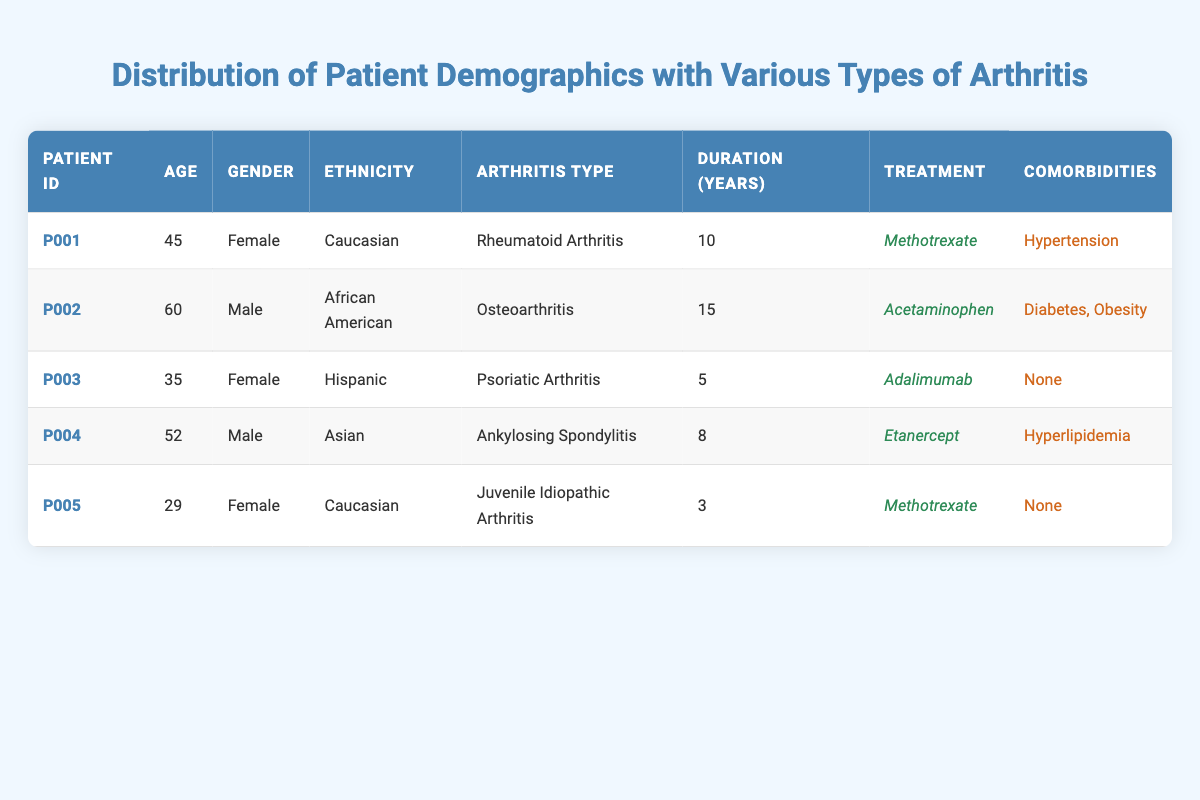What is the average age of the patients in the table? To find the average age, add together the ages of all patients (45 + 60 + 35 + 52 + 29 = 221) and divide by the number of patients (5). Thus, the average age is 221 / 5 = 44.2.
Answer: 44.2 How many patients have comorbidities? By examining the comorbidities column, it’s clear that patients P001, P002, and P004 have comorbidities. Therefore, there are three patients with comorbidities.
Answer: 3 Is there any patient who has been treated with Adalimumab? Patient P003 is listed in the table as receiving Adalimumab, confirming that there is indeed a patient using this treatment.
Answer: Yes What is the total duration of arthritis in years among all patients? To get the total duration, sum the duration years for all patients (10 + 15 + 5 + 8 + 3 = 41). This gives a total duration of 41 years among all patients.
Answer: 41 Which patient is the youngest, and what type of arthritis do they have? The youngest patient is P005, who is 29 years old and has Juvenile Idiopathic Arthritis. Looking at the ages, P005 is younger than the others.
Answer: P005, Juvenile Idiopathic Arthritis What is the gender distribution of the patients in the table? Analyzing the gender column, there are three females (P001, P003, P005) and two males (P002, P004). This means the gender distribution is 3 females and 2 males.
Answer: 3 females, 2 males Are there any patients who have "None" listed under comorbidities? By checking the comorbidities for each patient, P003 and P005 both have "None" listed, indicating there are patients without comorbidities.
Answer: Yes What percentage of the patients are aged 50 and above? Two patients (P002 and P004) are aged 50 and above out of a total of five patients. The percentage calculation is (2 / 5) * 100 = 40%.
Answer: 40% 